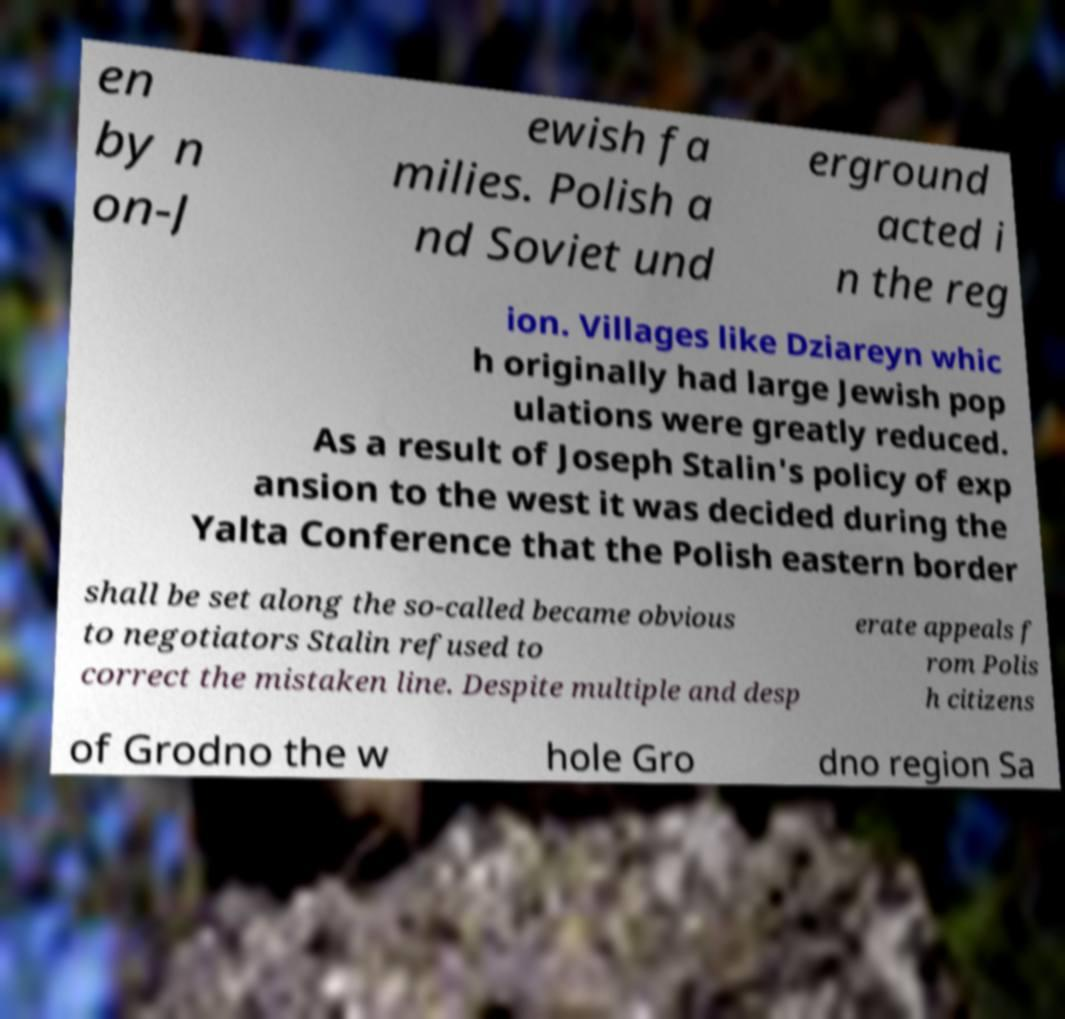Can you read and provide the text displayed in the image?This photo seems to have some interesting text. Can you extract and type it out for me? en by n on-J ewish fa milies. Polish a nd Soviet und erground acted i n the reg ion. Villages like Dziareyn whic h originally had large Jewish pop ulations were greatly reduced. As a result of Joseph Stalin's policy of exp ansion to the west it was decided during the Yalta Conference that the Polish eastern border shall be set along the so-called became obvious to negotiators Stalin refused to correct the mistaken line. Despite multiple and desp erate appeals f rom Polis h citizens of Grodno the w hole Gro dno region Sa 